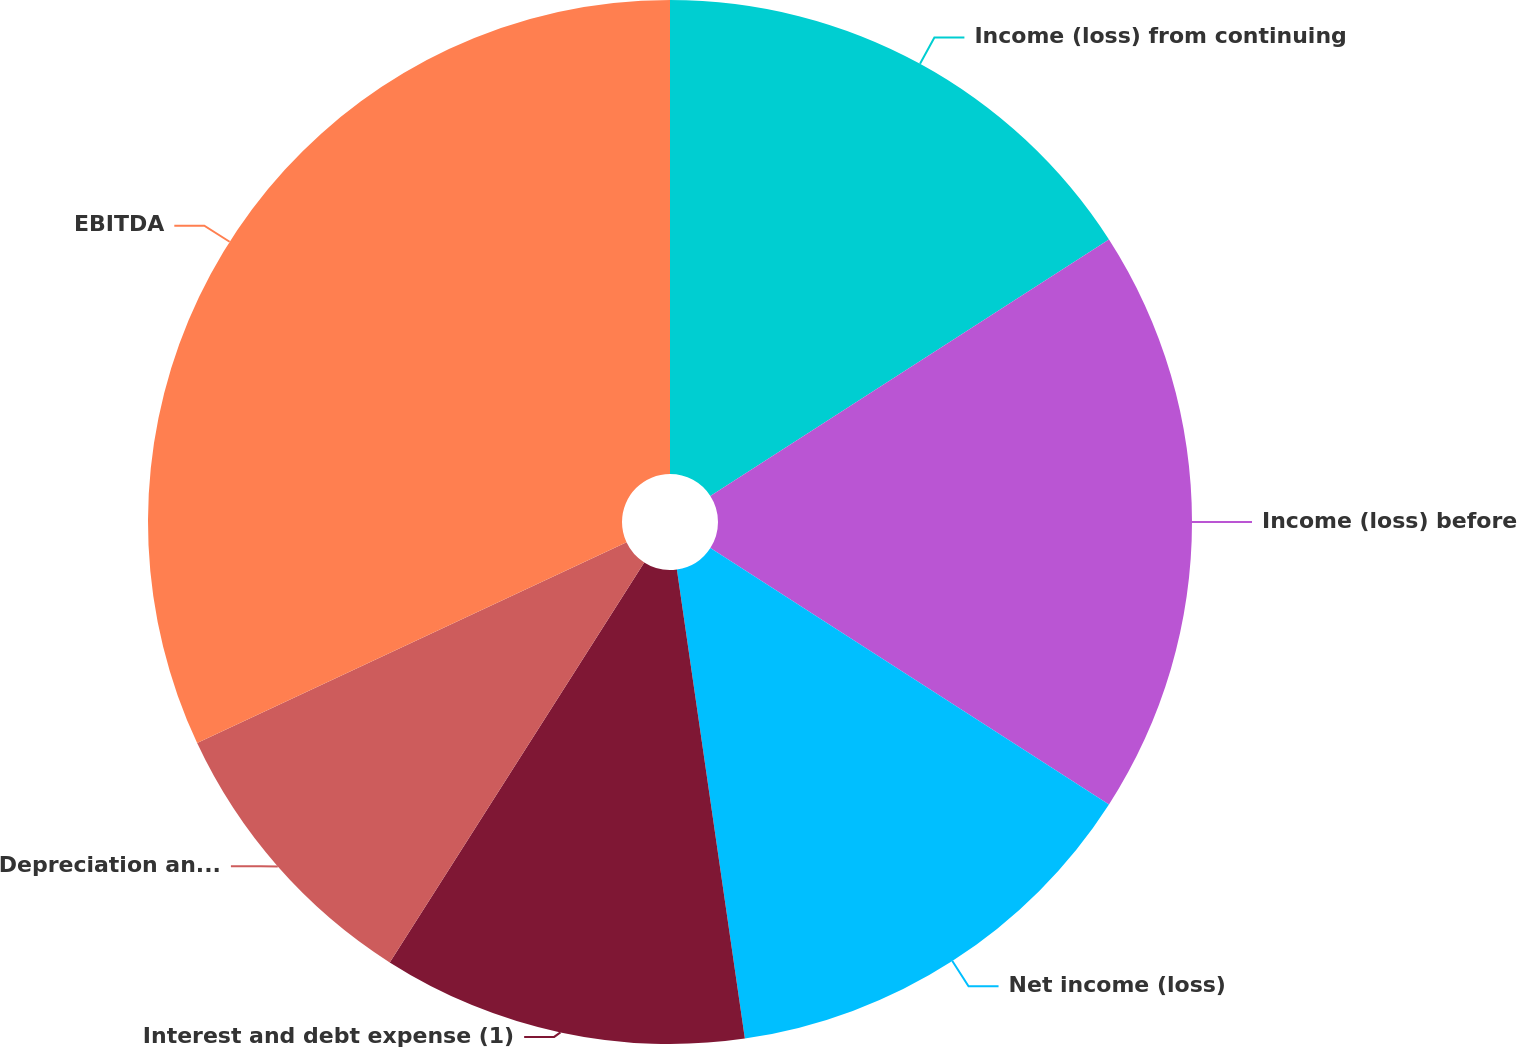Convert chart. <chart><loc_0><loc_0><loc_500><loc_500><pie_chart><fcel>Income (loss) from continuing<fcel>Income (loss) before<fcel>Net income (loss)<fcel>Interest and debt expense (1)<fcel>Depreciation and amortization<fcel>EBITDA<nl><fcel>15.9%<fcel>18.2%<fcel>13.61%<fcel>11.31%<fcel>9.02%<fcel>31.96%<nl></chart> 